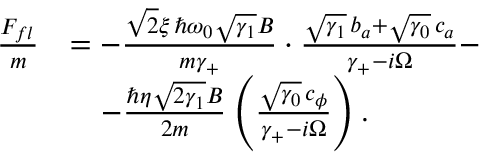Convert formula to latex. <formula><loc_0><loc_0><loc_500><loc_500>\begin{array} { r l } { \frac { F _ { f l } } { m } } & { = - \frac { \sqrt { 2 } \xi \, \hslash \omega _ { 0 } \sqrt { \gamma _ { 1 } } B } { m \gamma _ { + } } \cdot \frac { \sqrt { \gamma _ { 1 } } \, b _ { a } + \sqrt { \gamma _ { 0 } } \, c _ { a } } { \gamma _ { + } - i \Omega } - } \\ & { \quad - \frac { \hslash \eta \sqrt { 2 \gamma _ { 1 } } B } { 2 m } \left ( \frac { \sqrt { \gamma _ { 0 } } \, c _ { \phi } } { \gamma _ { + } - i \Omega } \right ) . } \end{array}</formula> 